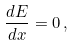<formula> <loc_0><loc_0><loc_500><loc_500>\frac { d E } { d x } = 0 \, ,</formula> 